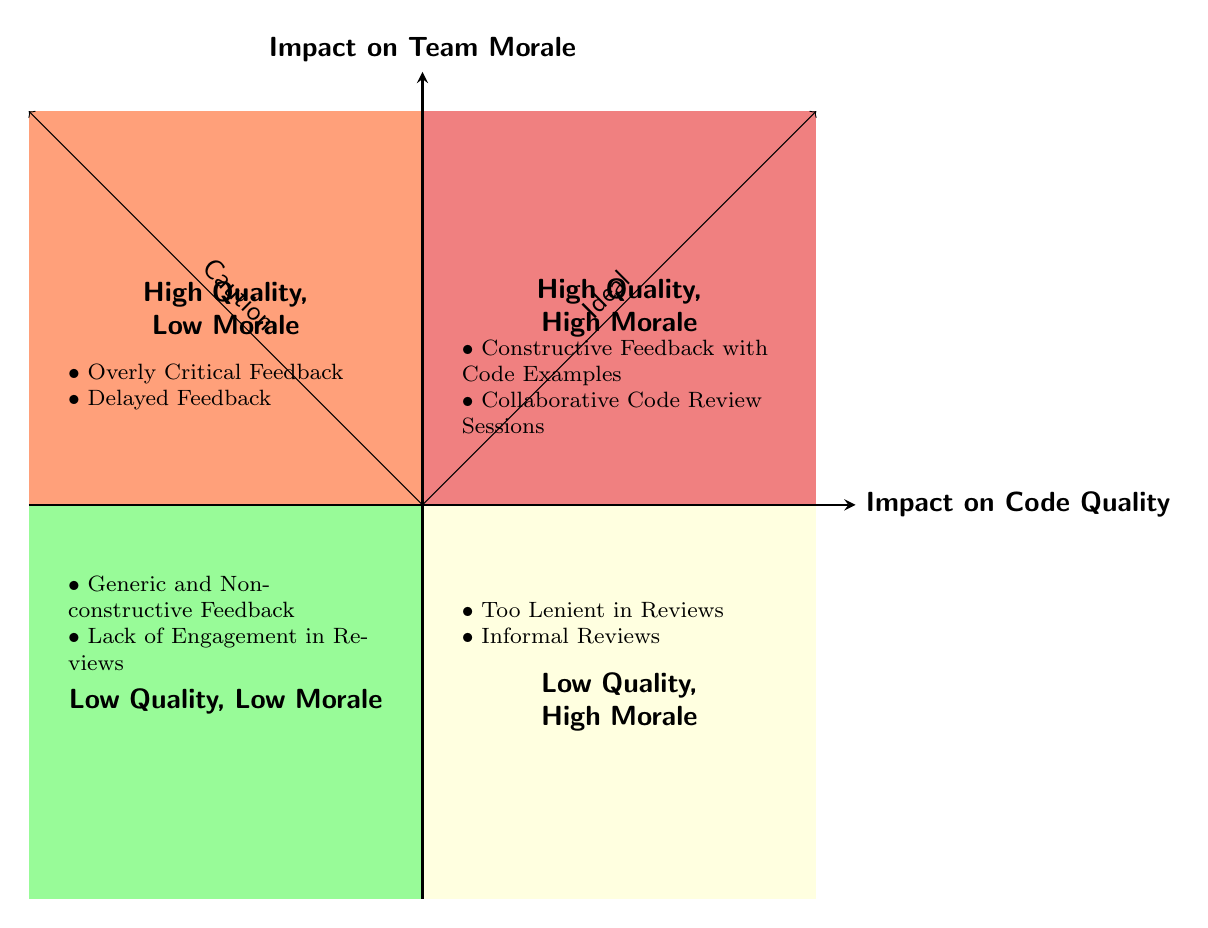What are the two quadrants that indicate high code quality? The quadrants with high code quality are identified as "High Quality, High Morale" and "High Quality, Low Morale". These quadrants are located at the upper right sector of the chart where the impact on code quality is high.
Answer: High Quality, High Morale; High Quality, Low Morale Which feedback example is found in the "Low Quality, High Morale" quadrant? In the "Low Quality, High Morale" quadrant, an example listed is "Too Lenient in Reviews". This is positioned in the lower right section of the chart where the morale is high but the code quality is low.
Answer: Too Lenient in Reviews How many examples are listed under the "High Quality, High Morale" quadrant? There are two examples provided under the "High Quality, High Morale" quadrant, which is in the upper right section of the chart.
Answer: Two What feedback situation leads to frustration in team members according to the diagram? The situation causing frustration among team members is "Delayed Feedback", which is categorized under the "High Quality, Low Morale" quadrant. This indicates that while the code quality is high, the lateness of the feedback negatively affects morale.
Answer: Delayed Feedback Which quadrant contains both high morale and low quality feedback examples? The quadrant that contains both high morale and low quality feedback examples is the "Low Quality, High Morale" quadrant, located in the lower right section of the chart.
Answer: Low Quality, High Morale In the diagram, what is indicated as the ideal direction? The ideal direction is indicated by the arrow that points from the "Low Quality, Low Morale" quadrant toward the "High Quality, High Morale" quadrant, suggesting improvement in both morale and the quality of code should be prioritized.
Answer: Ideal What type of feedback results in low morale but maintains high code quality? The type of feedback that results in low morale while maintaining high code quality is "Overly Critical Feedback", which is noted in the "High Quality, Low Morale" quadrant.
Answer: Overly Critical Feedback Which example showcases a lack of engagement in the review process? The example that showcases a lack of engagement in the review process is "Lack of Engagement in Reviews", found in the "Low Quality, Low Morale" quadrant.
Answer: Lack of Engagement in Reviews 